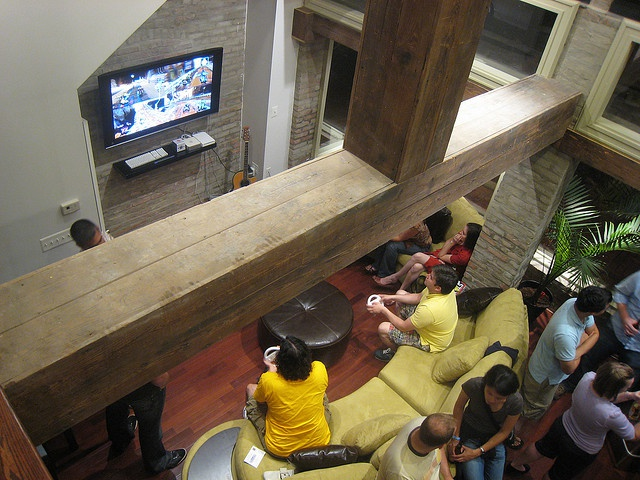Describe the objects in this image and their specific colors. I can see couch in darkgray, tan, black, and olive tones, tv in darkgray, white, black, navy, and lightblue tones, people in darkgray, orange, olive, black, and gold tones, potted plant in darkgray, black, darkgreen, and gray tones, and people in darkgray, black, and gray tones in this image. 